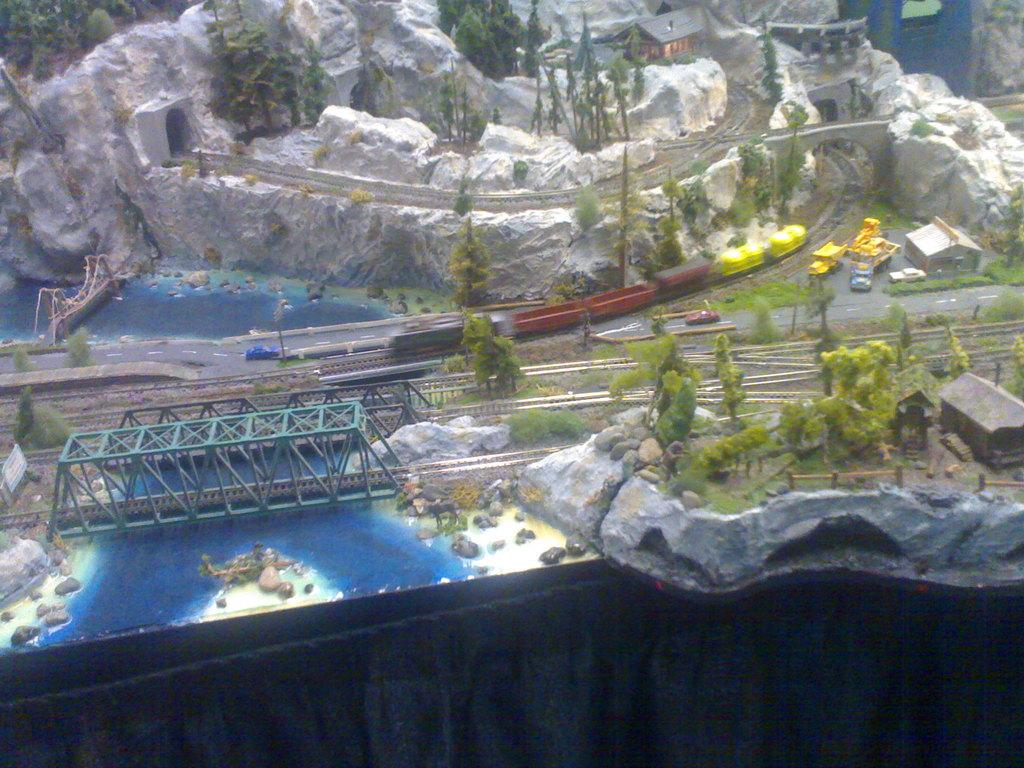What type of natural elements can be seen in the animation? There are trees, water, hills, and a cave in the animation. What man-made structures are present in the animation? There are bridges, houses, sheds, railway tracks, and a road in the animation. What type of transportation is depicted in the animation? There are vehicles in the animation. Can you tell me how many friends are depicted in the animation? There is no mention of friends in the provided facts, so it cannot be determined from the animation. Is there a coastline visible in the animation? There is no mention of a coastline in the provided facts, so it cannot be determined from the animation. 